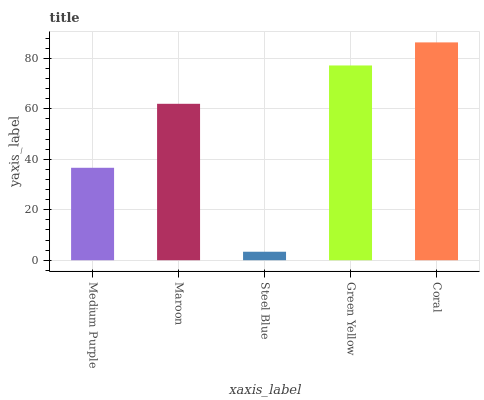Is Steel Blue the minimum?
Answer yes or no. Yes. Is Coral the maximum?
Answer yes or no. Yes. Is Maroon the minimum?
Answer yes or no. No. Is Maroon the maximum?
Answer yes or no. No. Is Maroon greater than Medium Purple?
Answer yes or no. Yes. Is Medium Purple less than Maroon?
Answer yes or no. Yes. Is Medium Purple greater than Maroon?
Answer yes or no. No. Is Maroon less than Medium Purple?
Answer yes or no. No. Is Maroon the high median?
Answer yes or no. Yes. Is Maroon the low median?
Answer yes or no. Yes. Is Green Yellow the high median?
Answer yes or no. No. Is Green Yellow the low median?
Answer yes or no. No. 